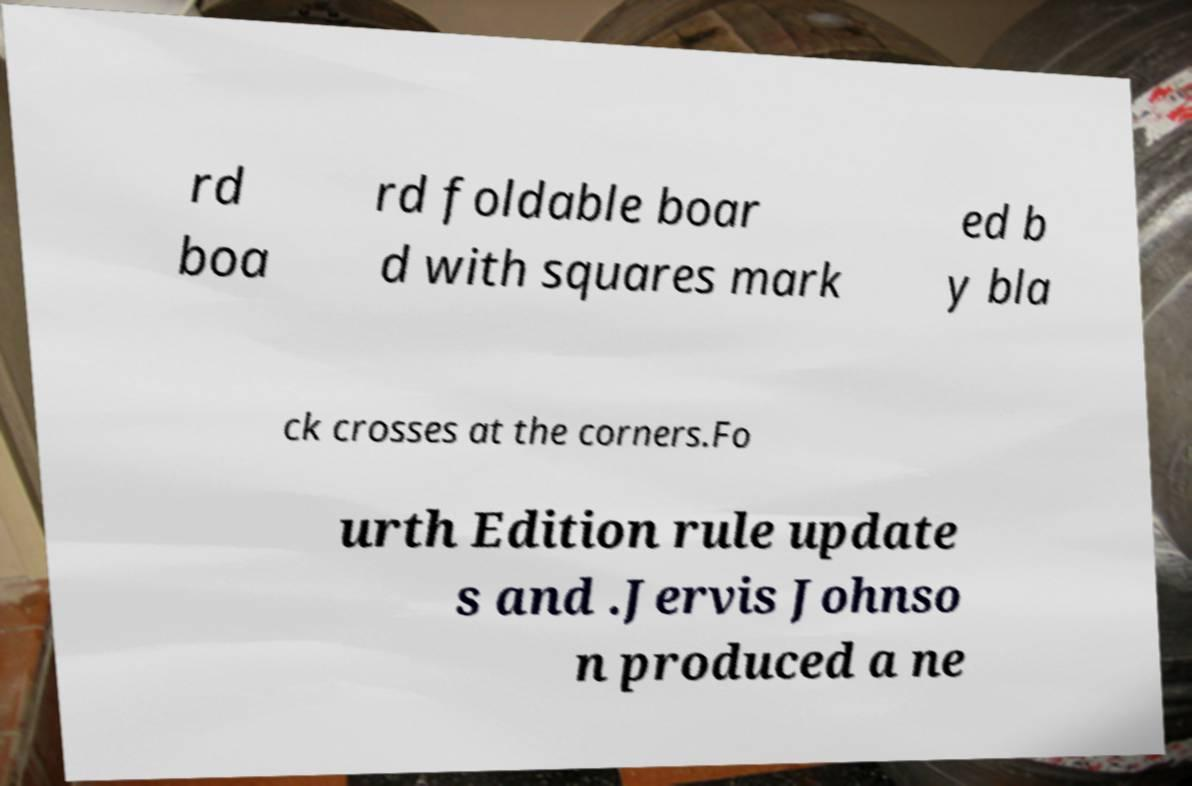Could you extract and type out the text from this image? rd boa rd foldable boar d with squares mark ed b y bla ck crosses at the corners.Fo urth Edition rule update s and .Jervis Johnso n produced a ne 